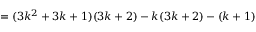Convert formula to latex. <formula><loc_0><loc_0><loc_500><loc_500>= ( 3 k ^ { 2 } + 3 k + 1 ) ( 3 k + 2 ) - k ( 3 k + 2 ) - ( k + 1 )</formula> 